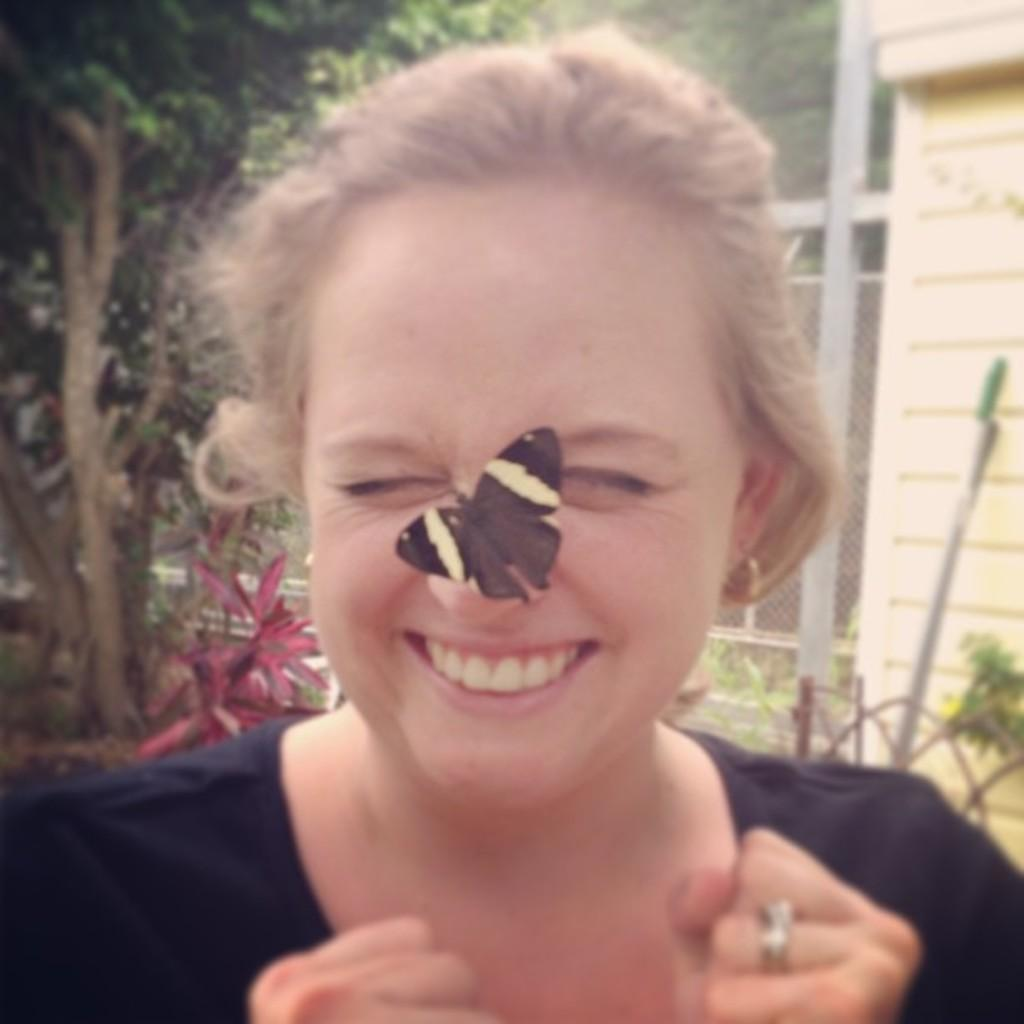What is the main subject of the image? There is a person in the image. What is the person wearing? The person is wearing a black t-shirt. What unusual detail can be seen on the person's face? There is a butterfly on the person's nose. What can be seen in the background of the image? There are trees, fencing, and a building in the background of the image. What type of reaction can be seen from the writer in the image? There is no writer present in the image, and therefore no reaction can be observed. 